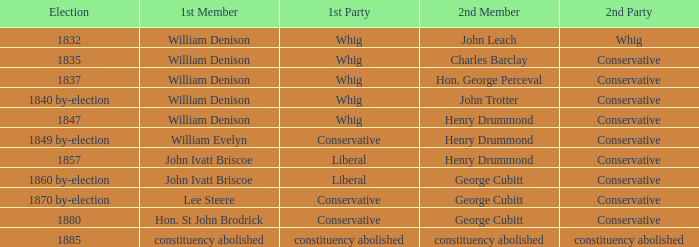Could you parse the entire table as a dict? {'header': ['Election', '1st Member', '1st Party', '2nd Member', '2nd Party'], 'rows': [['1832', 'William Denison', 'Whig', 'John Leach', 'Whig'], ['1835', 'William Denison', 'Whig', 'Charles Barclay', 'Conservative'], ['1837', 'William Denison', 'Whig', 'Hon. George Perceval', 'Conservative'], ['1840 by-election', 'William Denison', 'Whig', 'John Trotter', 'Conservative'], ['1847', 'William Denison', 'Whig', 'Henry Drummond', 'Conservative'], ['1849 by-election', 'William Evelyn', 'Conservative', 'Henry Drummond', 'Conservative'], ['1857', 'John Ivatt Briscoe', 'Liberal', 'Henry Drummond', 'Conservative'], ['1860 by-election', 'John Ivatt Briscoe', 'Liberal', 'George Cubitt', 'Conservative'], ['1870 by-election', 'Lee Steere', 'Conservative', 'George Cubitt', 'Conservative'], ['1880', 'Hon. St John Brodrick', 'Conservative', 'George Cubitt', 'Conservative'], ['1885', 'constituency abolished', 'constituency abolished', 'constituency abolished', 'constituency abolished']]} Which party's 1st member is John Ivatt Briscoe in an election in 1857? Liberal. 